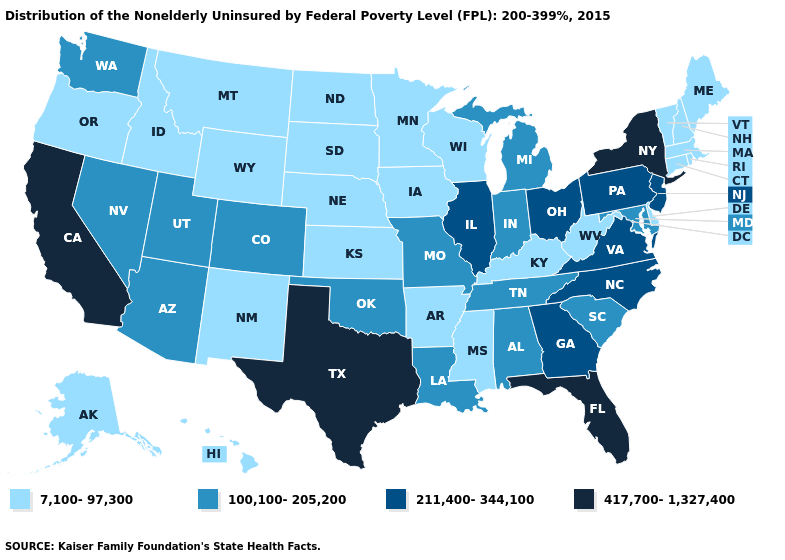What is the value of Pennsylvania?
Write a very short answer. 211,400-344,100. What is the value of South Dakota?
Give a very brief answer. 7,100-97,300. Name the states that have a value in the range 417,700-1,327,400?
Short answer required. California, Florida, New York, Texas. What is the value of Nebraska?
Give a very brief answer. 7,100-97,300. What is the lowest value in the South?
Give a very brief answer. 7,100-97,300. Among the states that border Georgia , which have the highest value?
Give a very brief answer. Florida. Name the states that have a value in the range 7,100-97,300?
Give a very brief answer. Alaska, Arkansas, Connecticut, Delaware, Hawaii, Idaho, Iowa, Kansas, Kentucky, Maine, Massachusetts, Minnesota, Mississippi, Montana, Nebraska, New Hampshire, New Mexico, North Dakota, Oregon, Rhode Island, South Dakota, Vermont, West Virginia, Wisconsin, Wyoming. Name the states that have a value in the range 211,400-344,100?
Concise answer only. Georgia, Illinois, New Jersey, North Carolina, Ohio, Pennsylvania, Virginia. Does Minnesota have the same value as New York?
Be succinct. No. Which states have the highest value in the USA?
Quick response, please. California, Florida, New York, Texas. Name the states that have a value in the range 417,700-1,327,400?
Quick response, please. California, Florida, New York, Texas. What is the highest value in states that border Alabama?
Concise answer only. 417,700-1,327,400. What is the value of Louisiana?
Write a very short answer. 100,100-205,200. What is the value of Texas?
Write a very short answer. 417,700-1,327,400. 